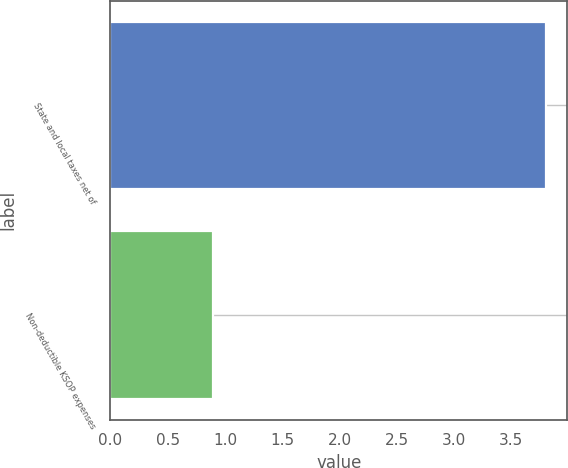Convert chart. <chart><loc_0><loc_0><loc_500><loc_500><bar_chart><fcel>State and local taxes net of<fcel>Non-deductible KSOP expenses<nl><fcel>3.8<fcel>0.9<nl></chart> 